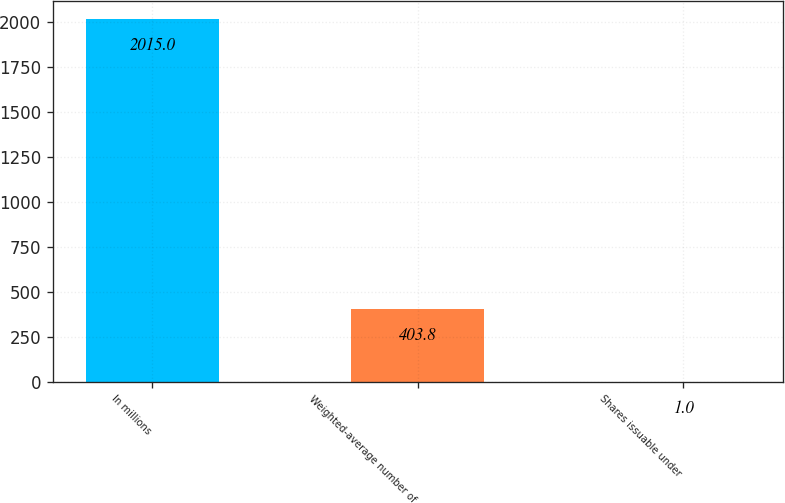Convert chart to OTSL. <chart><loc_0><loc_0><loc_500><loc_500><bar_chart><fcel>In millions<fcel>Weighted-average number of<fcel>Shares issuable under<nl><fcel>2015<fcel>403.8<fcel>1<nl></chart> 